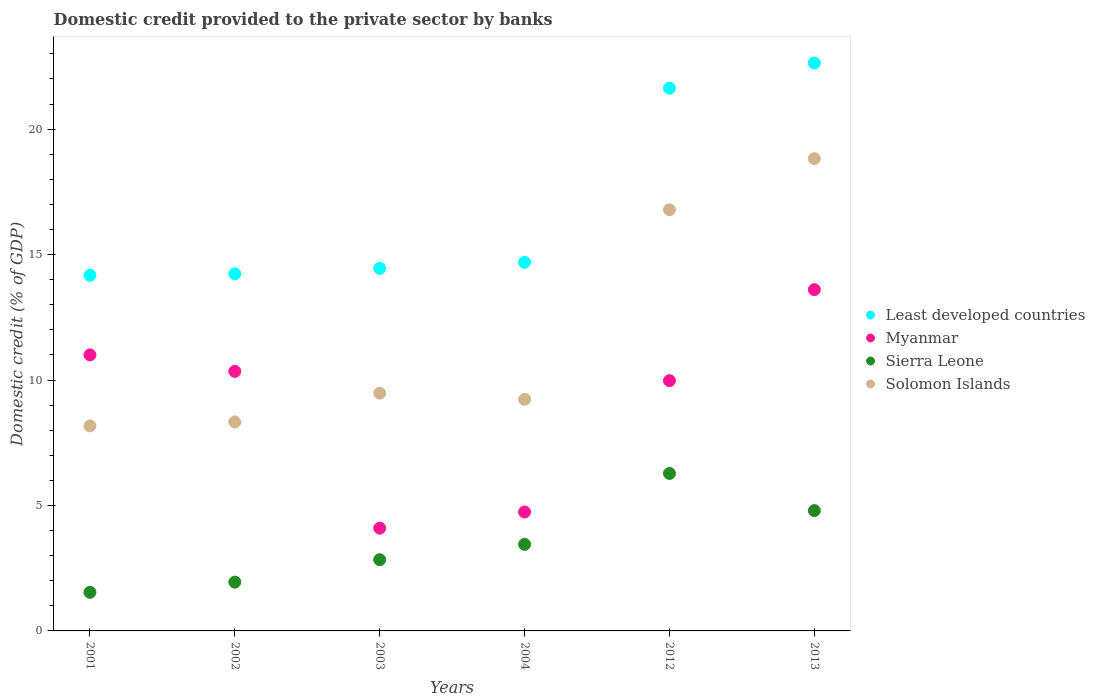What is the domestic credit provided to the private sector by banks in Sierra Leone in 2004?
Provide a short and direct response. 3.45. Across all years, what is the maximum domestic credit provided to the private sector by banks in Myanmar?
Give a very brief answer. 13.6. Across all years, what is the minimum domestic credit provided to the private sector by banks in Solomon Islands?
Offer a very short reply. 8.17. What is the total domestic credit provided to the private sector by banks in Least developed countries in the graph?
Your answer should be compact. 101.81. What is the difference between the domestic credit provided to the private sector by banks in Least developed countries in 2001 and that in 2012?
Keep it short and to the point. -7.46. What is the difference between the domestic credit provided to the private sector by banks in Sierra Leone in 2003 and the domestic credit provided to the private sector by banks in Solomon Islands in 2012?
Provide a short and direct response. -13.95. What is the average domestic credit provided to the private sector by banks in Sierra Leone per year?
Offer a very short reply. 3.47. In the year 2001, what is the difference between the domestic credit provided to the private sector by banks in Myanmar and domestic credit provided to the private sector by banks in Least developed countries?
Provide a short and direct response. -3.17. In how many years, is the domestic credit provided to the private sector by banks in Sierra Leone greater than 7 %?
Provide a short and direct response. 0. What is the ratio of the domestic credit provided to the private sector by banks in Solomon Islands in 2003 to that in 2012?
Your answer should be compact. 0.56. Is the domestic credit provided to the private sector by banks in Myanmar in 2001 less than that in 2002?
Provide a succinct answer. No. Is the difference between the domestic credit provided to the private sector by banks in Myanmar in 2002 and 2013 greater than the difference between the domestic credit provided to the private sector by banks in Least developed countries in 2002 and 2013?
Make the answer very short. Yes. What is the difference between the highest and the second highest domestic credit provided to the private sector by banks in Sierra Leone?
Offer a terse response. 1.48. What is the difference between the highest and the lowest domestic credit provided to the private sector by banks in Solomon Islands?
Offer a terse response. 10.65. Is the sum of the domestic credit provided to the private sector by banks in Sierra Leone in 2002 and 2012 greater than the maximum domestic credit provided to the private sector by banks in Least developed countries across all years?
Offer a very short reply. No. Is it the case that in every year, the sum of the domestic credit provided to the private sector by banks in Solomon Islands and domestic credit provided to the private sector by banks in Sierra Leone  is greater than the domestic credit provided to the private sector by banks in Myanmar?
Offer a very short reply. No. Does the domestic credit provided to the private sector by banks in Sierra Leone monotonically increase over the years?
Make the answer very short. No. How many dotlines are there?
Offer a terse response. 4. How many years are there in the graph?
Give a very brief answer. 6. Are the values on the major ticks of Y-axis written in scientific E-notation?
Provide a succinct answer. No. Where does the legend appear in the graph?
Ensure brevity in your answer.  Center right. How are the legend labels stacked?
Keep it short and to the point. Vertical. What is the title of the graph?
Your response must be concise. Domestic credit provided to the private sector by banks. Does "Malaysia" appear as one of the legend labels in the graph?
Make the answer very short. No. What is the label or title of the X-axis?
Offer a terse response. Years. What is the label or title of the Y-axis?
Provide a short and direct response. Domestic credit (% of GDP). What is the Domestic credit (% of GDP) of Least developed countries in 2001?
Your answer should be compact. 14.17. What is the Domestic credit (% of GDP) in Myanmar in 2001?
Offer a terse response. 11. What is the Domestic credit (% of GDP) of Sierra Leone in 2001?
Your answer should be very brief. 1.54. What is the Domestic credit (% of GDP) of Solomon Islands in 2001?
Keep it short and to the point. 8.17. What is the Domestic credit (% of GDP) of Least developed countries in 2002?
Make the answer very short. 14.23. What is the Domestic credit (% of GDP) in Myanmar in 2002?
Provide a short and direct response. 10.34. What is the Domestic credit (% of GDP) in Sierra Leone in 2002?
Ensure brevity in your answer.  1.94. What is the Domestic credit (% of GDP) in Solomon Islands in 2002?
Provide a succinct answer. 8.33. What is the Domestic credit (% of GDP) in Least developed countries in 2003?
Your answer should be very brief. 14.45. What is the Domestic credit (% of GDP) in Myanmar in 2003?
Provide a succinct answer. 4.1. What is the Domestic credit (% of GDP) in Sierra Leone in 2003?
Offer a very short reply. 2.84. What is the Domestic credit (% of GDP) in Solomon Islands in 2003?
Your answer should be very brief. 9.48. What is the Domestic credit (% of GDP) of Least developed countries in 2004?
Give a very brief answer. 14.69. What is the Domestic credit (% of GDP) of Myanmar in 2004?
Provide a short and direct response. 4.74. What is the Domestic credit (% of GDP) in Sierra Leone in 2004?
Your response must be concise. 3.45. What is the Domestic credit (% of GDP) of Solomon Islands in 2004?
Make the answer very short. 9.23. What is the Domestic credit (% of GDP) of Least developed countries in 2012?
Provide a succinct answer. 21.63. What is the Domestic credit (% of GDP) in Myanmar in 2012?
Keep it short and to the point. 9.97. What is the Domestic credit (% of GDP) of Sierra Leone in 2012?
Offer a very short reply. 6.28. What is the Domestic credit (% of GDP) in Solomon Islands in 2012?
Keep it short and to the point. 16.79. What is the Domestic credit (% of GDP) of Least developed countries in 2013?
Offer a terse response. 22.63. What is the Domestic credit (% of GDP) in Myanmar in 2013?
Provide a short and direct response. 13.6. What is the Domestic credit (% of GDP) in Sierra Leone in 2013?
Ensure brevity in your answer.  4.79. What is the Domestic credit (% of GDP) of Solomon Islands in 2013?
Offer a very short reply. 18.82. Across all years, what is the maximum Domestic credit (% of GDP) of Least developed countries?
Your answer should be compact. 22.63. Across all years, what is the maximum Domestic credit (% of GDP) of Myanmar?
Offer a terse response. 13.6. Across all years, what is the maximum Domestic credit (% of GDP) in Sierra Leone?
Offer a very short reply. 6.28. Across all years, what is the maximum Domestic credit (% of GDP) in Solomon Islands?
Keep it short and to the point. 18.82. Across all years, what is the minimum Domestic credit (% of GDP) in Least developed countries?
Make the answer very short. 14.17. Across all years, what is the minimum Domestic credit (% of GDP) of Myanmar?
Offer a very short reply. 4.1. Across all years, what is the minimum Domestic credit (% of GDP) in Sierra Leone?
Give a very brief answer. 1.54. Across all years, what is the minimum Domestic credit (% of GDP) of Solomon Islands?
Provide a succinct answer. 8.17. What is the total Domestic credit (% of GDP) of Least developed countries in the graph?
Offer a very short reply. 101.81. What is the total Domestic credit (% of GDP) of Myanmar in the graph?
Give a very brief answer. 53.76. What is the total Domestic credit (% of GDP) in Sierra Leone in the graph?
Provide a short and direct response. 20.84. What is the total Domestic credit (% of GDP) of Solomon Islands in the graph?
Provide a short and direct response. 70.82. What is the difference between the Domestic credit (% of GDP) in Least developed countries in 2001 and that in 2002?
Make the answer very short. -0.06. What is the difference between the Domestic credit (% of GDP) in Myanmar in 2001 and that in 2002?
Offer a terse response. 0.66. What is the difference between the Domestic credit (% of GDP) in Sierra Leone in 2001 and that in 2002?
Your answer should be very brief. -0.41. What is the difference between the Domestic credit (% of GDP) of Solomon Islands in 2001 and that in 2002?
Your answer should be compact. -0.16. What is the difference between the Domestic credit (% of GDP) of Least developed countries in 2001 and that in 2003?
Keep it short and to the point. -0.28. What is the difference between the Domestic credit (% of GDP) in Myanmar in 2001 and that in 2003?
Your answer should be very brief. 6.91. What is the difference between the Domestic credit (% of GDP) of Sierra Leone in 2001 and that in 2003?
Your answer should be very brief. -1.3. What is the difference between the Domestic credit (% of GDP) in Solomon Islands in 2001 and that in 2003?
Provide a short and direct response. -1.31. What is the difference between the Domestic credit (% of GDP) in Least developed countries in 2001 and that in 2004?
Your response must be concise. -0.52. What is the difference between the Domestic credit (% of GDP) in Myanmar in 2001 and that in 2004?
Your response must be concise. 6.26. What is the difference between the Domestic credit (% of GDP) of Sierra Leone in 2001 and that in 2004?
Give a very brief answer. -1.91. What is the difference between the Domestic credit (% of GDP) of Solomon Islands in 2001 and that in 2004?
Provide a short and direct response. -1.06. What is the difference between the Domestic credit (% of GDP) in Least developed countries in 2001 and that in 2012?
Your response must be concise. -7.46. What is the difference between the Domestic credit (% of GDP) in Myanmar in 2001 and that in 2012?
Give a very brief answer. 1.03. What is the difference between the Domestic credit (% of GDP) in Sierra Leone in 2001 and that in 2012?
Offer a terse response. -4.74. What is the difference between the Domestic credit (% of GDP) in Solomon Islands in 2001 and that in 2012?
Give a very brief answer. -8.61. What is the difference between the Domestic credit (% of GDP) in Least developed countries in 2001 and that in 2013?
Ensure brevity in your answer.  -8.46. What is the difference between the Domestic credit (% of GDP) in Myanmar in 2001 and that in 2013?
Provide a short and direct response. -2.6. What is the difference between the Domestic credit (% of GDP) of Sierra Leone in 2001 and that in 2013?
Your answer should be very brief. -3.26. What is the difference between the Domestic credit (% of GDP) of Solomon Islands in 2001 and that in 2013?
Offer a terse response. -10.65. What is the difference between the Domestic credit (% of GDP) in Least developed countries in 2002 and that in 2003?
Give a very brief answer. -0.22. What is the difference between the Domestic credit (% of GDP) of Myanmar in 2002 and that in 2003?
Offer a very short reply. 6.25. What is the difference between the Domestic credit (% of GDP) in Sierra Leone in 2002 and that in 2003?
Keep it short and to the point. -0.89. What is the difference between the Domestic credit (% of GDP) in Solomon Islands in 2002 and that in 2003?
Make the answer very short. -1.15. What is the difference between the Domestic credit (% of GDP) in Least developed countries in 2002 and that in 2004?
Offer a terse response. -0.46. What is the difference between the Domestic credit (% of GDP) of Myanmar in 2002 and that in 2004?
Your answer should be compact. 5.6. What is the difference between the Domestic credit (% of GDP) in Sierra Leone in 2002 and that in 2004?
Provide a short and direct response. -1.51. What is the difference between the Domestic credit (% of GDP) of Solomon Islands in 2002 and that in 2004?
Offer a terse response. -0.9. What is the difference between the Domestic credit (% of GDP) of Least developed countries in 2002 and that in 2012?
Your response must be concise. -7.4. What is the difference between the Domestic credit (% of GDP) in Myanmar in 2002 and that in 2012?
Give a very brief answer. 0.37. What is the difference between the Domestic credit (% of GDP) of Sierra Leone in 2002 and that in 2012?
Ensure brevity in your answer.  -4.33. What is the difference between the Domestic credit (% of GDP) in Solomon Islands in 2002 and that in 2012?
Your answer should be compact. -8.46. What is the difference between the Domestic credit (% of GDP) in Least developed countries in 2002 and that in 2013?
Provide a short and direct response. -8.4. What is the difference between the Domestic credit (% of GDP) in Myanmar in 2002 and that in 2013?
Give a very brief answer. -3.26. What is the difference between the Domestic credit (% of GDP) in Sierra Leone in 2002 and that in 2013?
Your answer should be compact. -2.85. What is the difference between the Domestic credit (% of GDP) of Solomon Islands in 2002 and that in 2013?
Your answer should be very brief. -10.5. What is the difference between the Domestic credit (% of GDP) of Least developed countries in 2003 and that in 2004?
Ensure brevity in your answer.  -0.24. What is the difference between the Domestic credit (% of GDP) of Myanmar in 2003 and that in 2004?
Your answer should be very brief. -0.64. What is the difference between the Domestic credit (% of GDP) in Sierra Leone in 2003 and that in 2004?
Keep it short and to the point. -0.61. What is the difference between the Domestic credit (% of GDP) of Solomon Islands in 2003 and that in 2004?
Give a very brief answer. 0.25. What is the difference between the Domestic credit (% of GDP) of Least developed countries in 2003 and that in 2012?
Offer a very short reply. -7.18. What is the difference between the Domestic credit (% of GDP) in Myanmar in 2003 and that in 2012?
Provide a short and direct response. -5.88. What is the difference between the Domestic credit (% of GDP) of Sierra Leone in 2003 and that in 2012?
Your response must be concise. -3.44. What is the difference between the Domestic credit (% of GDP) in Solomon Islands in 2003 and that in 2012?
Keep it short and to the point. -7.31. What is the difference between the Domestic credit (% of GDP) of Least developed countries in 2003 and that in 2013?
Your response must be concise. -8.18. What is the difference between the Domestic credit (% of GDP) in Myanmar in 2003 and that in 2013?
Ensure brevity in your answer.  -9.51. What is the difference between the Domestic credit (% of GDP) of Sierra Leone in 2003 and that in 2013?
Provide a short and direct response. -1.96. What is the difference between the Domestic credit (% of GDP) in Solomon Islands in 2003 and that in 2013?
Provide a succinct answer. -9.35. What is the difference between the Domestic credit (% of GDP) in Least developed countries in 2004 and that in 2012?
Keep it short and to the point. -6.94. What is the difference between the Domestic credit (% of GDP) of Myanmar in 2004 and that in 2012?
Provide a succinct answer. -5.23. What is the difference between the Domestic credit (% of GDP) in Sierra Leone in 2004 and that in 2012?
Ensure brevity in your answer.  -2.83. What is the difference between the Domestic credit (% of GDP) of Solomon Islands in 2004 and that in 2012?
Provide a succinct answer. -7.55. What is the difference between the Domestic credit (% of GDP) in Least developed countries in 2004 and that in 2013?
Make the answer very short. -7.94. What is the difference between the Domestic credit (% of GDP) in Myanmar in 2004 and that in 2013?
Give a very brief answer. -8.86. What is the difference between the Domestic credit (% of GDP) in Sierra Leone in 2004 and that in 2013?
Make the answer very short. -1.35. What is the difference between the Domestic credit (% of GDP) of Solomon Islands in 2004 and that in 2013?
Your answer should be very brief. -9.59. What is the difference between the Domestic credit (% of GDP) of Least developed countries in 2012 and that in 2013?
Make the answer very short. -1. What is the difference between the Domestic credit (% of GDP) in Myanmar in 2012 and that in 2013?
Make the answer very short. -3.63. What is the difference between the Domestic credit (% of GDP) in Sierra Leone in 2012 and that in 2013?
Your response must be concise. 1.48. What is the difference between the Domestic credit (% of GDP) of Solomon Islands in 2012 and that in 2013?
Provide a short and direct response. -2.04. What is the difference between the Domestic credit (% of GDP) in Least developed countries in 2001 and the Domestic credit (% of GDP) in Myanmar in 2002?
Keep it short and to the point. 3.83. What is the difference between the Domestic credit (% of GDP) of Least developed countries in 2001 and the Domestic credit (% of GDP) of Sierra Leone in 2002?
Your answer should be very brief. 12.23. What is the difference between the Domestic credit (% of GDP) of Least developed countries in 2001 and the Domestic credit (% of GDP) of Solomon Islands in 2002?
Keep it short and to the point. 5.84. What is the difference between the Domestic credit (% of GDP) of Myanmar in 2001 and the Domestic credit (% of GDP) of Sierra Leone in 2002?
Your response must be concise. 9.06. What is the difference between the Domestic credit (% of GDP) of Myanmar in 2001 and the Domestic credit (% of GDP) of Solomon Islands in 2002?
Your answer should be compact. 2.67. What is the difference between the Domestic credit (% of GDP) of Sierra Leone in 2001 and the Domestic credit (% of GDP) of Solomon Islands in 2002?
Give a very brief answer. -6.79. What is the difference between the Domestic credit (% of GDP) of Least developed countries in 2001 and the Domestic credit (% of GDP) of Myanmar in 2003?
Your answer should be very brief. 10.08. What is the difference between the Domestic credit (% of GDP) in Least developed countries in 2001 and the Domestic credit (% of GDP) in Sierra Leone in 2003?
Provide a succinct answer. 11.33. What is the difference between the Domestic credit (% of GDP) in Least developed countries in 2001 and the Domestic credit (% of GDP) in Solomon Islands in 2003?
Offer a terse response. 4.69. What is the difference between the Domestic credit (% of GDP) of Myanmar in 2001 and the Domestic credit (% of GDP) of Sierra Leone in 2003?
Offer a terse response. 8.16. What is the difference between the Domestic credit (% of GDP) of Myanmar in 2001 and the Domestic credit (% of GDP) of Solomon Islands in 2003?
Your response must be concise. 1.53. What is the difference between the Domestic credit (% of GDP) in Sierra Leone in 2001 and the Domestic credit (% of GDP) in Solomon Islands in 2003?
Your answer should be very brief. -7.94. What is the difference between the Domestic credit (% of GDP) in Least developed countries in 2001 and the Domestic credit (% of GDP) in Myanmar in 2004?
Your response must be concise. 9.43. What is the difference between the Domestic credit (% of GDP) in Least developed countries in 2001 and the Domestic credit (% of GDP) in Sierra Leone in 2004?
Make the answer very short. 10.72. What is the difference between the Domestic credit (% of GDP) of Least developed countries in 2001 and the Domestic credit (% of GDP) of Solomon Islands in 2004?
Offer a very short reply. 4.94. What is the difference between the Domestic credit (% of GDP) in Myanmar in 2001 and the Domestic credit (% of GDP) in Sierra Leone in 2004?
Make the answer very short. 7.55. What is the difference between the Domestic credit (% of GDP) of Myanmar in 2001 and the Domestic credit (% of GDP) of Solomon Islands in 2004?
Ensure brevity in your answer.  1.77. What is the difference between the Domestic credit (% of GDP) in Sierra Leone in 2001 and the Domestic credit (% of GDP) in Solomon Islands in 2004?
Your response must be concise. -7.69. What is the difference between the Domestic credit (% of GDP) of Least developed countries in 2001 and the Domestic credit (% of GDP) of Myanmar in 2012?
Provide a short and direct response. 4.2. What is the difference between the Domestic credit (% of GDP) of Least developed countries in 2001 and the Domestic credit (% of GDP) of Sierra Leone in 2012?
Keep it short and to the point. 7.89. What is the difference between the Domestic credit (% of GDP) of Least developed countries in 2001 and the Domestic credit (% of GDP) of Solomon Islands in 2012?
Offer a very short reply. -2.61. What is the difference between the Domestic credit (% of GDP) in Myanmar in 2001 and the Domestic credit (% of GDP) in Sierra Leone in 2012?
Provide a short and direct response. 4.72. What is the difference between the Domestic credit (% of GDP) of Myanmar in 2001 and the Domestic credit (% of GDP) of Solomon Islands in 2012?
Your answer should be very brief. -5.78. What is the difference between the Domestic credit (% of GDP) of Sierra Leone in 2001 and the Domestic credit (% of GDP) of Solomon Islands in 2012?
Provide a short and direct response. -15.25. What is the difference between the Domestic credit (% of GDP) of Least developed countries in 2001 and the Domestic credit (% of GDP) of Myanmar in 2013?
Ensure brevity in your answer.  0.57. What is the difference between the Domestic credit (% of GDP) in Least developed countries in 2001 and the Domestic credit (% of GDP) in Sierra Leone in 2013?
Provide a short and direct response. 9.38. What is the difference between the Domestic credit (% of GDP) in Least developed countries in 2001 and the Domestic credit (% of GDP) in Solomon Islands in 2013?
Provide a succinct answer. -4.65. What is the difference between the Domestic credit (% of GDP) in Myanmar in 2001 and the Domestic credit (% of GDP) in Sierra Leone in 2013?
Offer a terse response. 6.21. What is the difference between the Domestic credit (% of GDP) of Myanmar in 2001 and the Domestic credit (% of GDP) of Solomon Islands in 2013?
Offer a terse response. -7.82. What is the difference between the Domestic credit (% of GDP) of Sierra Leone in 2001 and the Domestic credit (% of GDP) of Solomon Islands in 2013?
Provide a short and direct response. -17.29. What is the difference between the Domestic credit (% of GDP) in Least developed countries in 2002 and the Domestic credit (% of GDP) in Myanmar in 2003?
Provide a succinct answer. 10.14. What is the difference between the Domestic credit (% of GDP) of Least developed countries in 2002 and the Domestic credit (% of GDP) of Sierra Leone in 2003?
Provide a succinct answer. 11.39. What is the difference between the Domestic credit (% of GDP) in Least developed countries in 2002 and the Domestic credit (% of GDP) in Solomon Islands in 2003?
Keep it short and to the point. 4.76. What is the difference between the Domestic credit (% of GDP) in Myanmar in 2002 and the Domestic credit (% of GDP) in Sierra Leone in 2003?
Make the answer very short. 7.51. What is the difference between the Domestic credit (% of GDP) of Myanmar in 2002 and the Domestic credit (% of GDP) of Solomon Islands in 2003?
Keep it short and to the point. 0.87. What is the difference between the Domestic credit (% of GDP) in Sierra Leone in 2002 and the Domestic credit (% of GDP) in Solomon Islands in 2003?
Provide a short and direct response. -7.53. What is the difference between the Domestic credit (% of GDP) of Least developed countries in 2002 and the Domestic credit (% of GDP) of Myanmar in 2004?
Keep it short and to the point. 9.49. What is the difference between the Domestic credit (% of GDP) in Least developed countries in 2002 and the Domestic credit (% of GDP) in Sierra Leone in 2004?
Your answer should be compact. 10.78. What is the difference between the Domestic credit (% of GDP) in Least developed countries in 2002 and the Domestic credit (% of GDP) in Solomon Islands in 2004?
Provide a short and direct response. 5. What is the difference between the Domestic credit (% of GDP) in Myanmar in 2002 and the Domestic credit (% of GDP) in Sierra Leone in 2004?
Make the answer very short. 6.9. What is the difference between the Domestic credit (% of GDP) in Myanmar in 2002 and the Domestic credit (% of GDP) in Solomon Islands in 2004?
Provide a short and direct response. 1.11. What is the difference between the Domestic credit (% of GDP) of Sierra Leone in 2002 and the Domestic credit (% of GDP) of Solomon Islands in 2004?
Your response must be concise. -7.29. What is the difference between the Domestic credit (% of GDP) of Least developed countries in 2002 and the Domestic credit (% of GDP) of Myanmar in 2012?
Your response must be concise. 4.26. What is the difference between the Domestic credit (% of GDP) of Least developed countries in 2002 and the Domestic credit (% of GDP) of Sierra Leone in 2012?
Your response must be concise. 7.95. What is the difference between the Domestic credit (% of GDP) in Least developed countries in 2002 and the Domestic credit (% of GDP) in Solomon Islands in 2012?
Ensure brevity in your answer.  -2.55. What is the difference between the Domestic credit (% of GDP) of Myanmar in 2002 and the Domestic credit (% of GDP) of Sierra Leone in 2012?
Offer a terse response. 4.07. What is the difference between the Domestic credit (% of GDP) in Myanmar in 2002 and the Domestic credit (% of GDP) in Solomon Islands in 2012?
Offer a very short reply. -6.44. What is the difference between the Domestic credit (% of GDP) in Sierra Leone in 2002 and the Domestic credit (% of GDP) in Solomon Islands in 2012?
Your answer should be compact. -14.84. What is the difference between the Domestic credit (% of GDP) in Least developed countries in 2002 and the Domestic credit (% of GDP) in Myanmar in 2013?
Offer a terse response. 0.63. What is the difference between the Domestic credit (% of GDP) in Least developed countries in 2002 and the Domestic credit (% of GDP) in Sierra Leone in 2013?
Your response must be concise. 9.44. What is the difference between the Domestic credit (% of GDP) of Least developed countries in 2002 and the Domestic credit (% of GDP) of Solomon Islands in 2013?
Your response must be concise. -4.59. What is the difference between the Domestic credit (% of GDP) in Myanmar in 2002 and the Domestic credit (% of GDP) in Sierra Leone in 2013?
Give a very brief answer. 5.55. What is the difference between the Domestic credit (% of GDP) in Myanmar in 2002 and the Domestic credit (% of GDP) in Solomon Islands in 2013?
Ensure brevity in your answer.  -8.48. What is the difference between the Domestic credit (% of GDP) in Sierra Leone in 2002 and the Domestic credit (% of GDP) in Solomon Islands in 2013?
Your response must be concise. -16.88. What is the difference between the Domestic credit (% of GDP) in Least developed countries in 2003 and the Domestic credit (% of GDP) in Myanmar in 2004?
Keep it short and to the point. 9.71. What is the difference between the Domestic credit (% of GDP) of Least developed countries in 2003 and the Domestic credit (% of GDP) of Sierra Leone in 2004?
Provide a short and direct response. 11. What is the difference between the Domestic credit (% of GDP) of Least developed countries in 2003 and the Domestic credit (% of GDP) of Solomon Islands in 2004?
Provide a succinct answer. 5.22. What is the difference between the Domestic credit (% of GDP) of Myanmar in 2003 and the Domestic credit (% of GDP) of Sierra Leone in 2004?
Make the answer very short. 0.65. What is the difference between the Domestic credit (% of GDP) in Myanmar in 2003 and the Domestic credit (% of GDP) in Solomon Islands in 2004?
Your answer should be very brief. -5.14. What is the difference between the Domestic credit (% of GDP) of Sierra Leone in 2003 and the Domestic credit (% of GDP) of Solomon Islands in 2004?
Provide a succinct answer. -6.39. What is the difference between the Domestic credit (% of GDP) of Least developed countries in 2003 and the Domestic credit (% of GDP) of Myanmar in 2012?
Provide a short and direct response. 4.48. What is the difference between the Domestic credit (% of GDP) of Least developed countries in 2003 and the Domestic credit (% of GDP) of Sierra Leone in 2012?
Keep it short and to the point. 8.17. What is the difference between the Domestic credit (% of GDP) in Least developed countries in 2003 and the Domestic credit (% of GDP) in Solomon Islands in 2012?
Provide a succinct answer. -2.34. What is the difference between the Domestic credit (% of GDP) of Myanmar in 2003 and the Domestic credit (% of GDP) of Sierra Leone in 2012?
Your answer should be very brief. -2.18. What is the difference between the Domestic credit (% of GDP) of Myanmar in 2003 and the Domestic credit (% of GDP) of Solomon Islands in 2012?
Give a very brief answer. -12.69. What is the difference between the Domestic credit (% of GDP) of Sierra Leone in 2003 and the Domestic credit (% of GDP) of Solomon Islands in 2012?
Offer a very short reply. -13.95. What is the difference between the Domestic credit (% of GDP) of Least developed countries in 2003 and the Domestic credit (% of GDP) of Myanmar in 2013?
Provide a succinct answer. 0.85. What is the difference between the Domestic credit (% of GDP) of Least developed countries in 2003 and the Domestic credit (% of GDP) of Sierra Leone in 2013?
Ensure brevity in your answer.  9.65. What is the difference between the Domestic credit (% of GDP) in Least developed countries in 2003 and the Domestic credit (% of GDP) in Solomon Islands in 2013?
Offer a terse response. -4.37. What is the difference between the Domestic credit (% of GDP) of Myanmar in 2003 and the Domestic credit (% of GDP) of Sierra Leone in 2013?
Offer a terse response. -0.7. What is the difference between the Domestic credit (% of GDP) of Myanmar in 2003 and the Domestic credit (% of GDP) of Solomon Islands in 2013?
Provide a short and direct response. -14.73. What is the difference between the Domestic credit (% of GDP) of Sierra Leone in 2003 and the Domestic credit (% of GDP) of Solomon Islands in 2013?
Offer a terse response. -15.98. What is the difference between the Domestic credit (% of GDP) of Least developed countries in 2004 and the Domestic credit (% of GDP) of Myanmar in 2012?
Your answer should be compact. 4.72. What is the difference between the Domestic credit (% of GDP) of Least developed countries in 2004 and the Domestic credit (% of GDP) of Sierra Leone in 2012?
Make the answer very short. 8.41. What is the difference between the Domestic credit (% of GDP) in Least developed countries in 2004 and the Domestic credit (% of GDP) in Solomon Islands in 2012?
Your answer should be compact. -2.09. What is the difference between the Domestic credit (% of GDP) of Myanmar in 2004 and the Domestic credit (% of GDP) of Sierra Leone in 2012?
Your answer should be very brief. -1.54. What is the difference between the Domestic credit (% of GDP) of Myanmar in 2004 and the Domestic credit (% of GDP) of Solomon Islands in 2012?
Your response must be concise. -12.05. What is the difference between the Domestic credit (% of GDP) in Sierra Leone in 2004 and the Domestic credit (% of GDP) in Solomon Islands in 2012?
Ensure brevity in your answer.  -13.34. What is the difference between the Domestic credit (% of GDP) of Least developed countries in 2004 and the Domestic credit (% of GDP) of Myanmar in 2013?
Offer a very short reply. 1.09. What is the difference between the Domestic credit (% of GDP) of Least developed countries in 2004 and the Domestic credit (% of GDP) of Sierra Leone in 2013?
Your answer should be very brief. 9.9. What is the difference between the Domestic credit (% of GDP) in Least developed countries in 2004 and the Domestic credit (% of GDP) in Solomon Islands in 2013?
Your answer should be very brief. -4.13. What is the difference between the Domestic credit (% of GDP) of Myanmar in 2004 and the Domestic credit (% of GDP) of Sierra Leone in 2013?
Give a very brief answer. -0.05. What is the difference between the Domestic credit (% of GDP) in Myanmar in 2004 and the Domestic credit (% of GDP) in Solomon Islands in 2013?
Provide a short and direct response. -14.08. What is the difference between the Domestic credit (% of GDP) in Sierra Leone in 2004 and the Domestic credit (% of GDP) in Solomon Islands in 2013?
Provide a succinct answer. -15.37. What is the difference between the Domestic credit (% of GDP) of Least developed countries in 2012 and the Domestic credit (% of GDP) of Myanmar in 2013?
Keep it short and to the point. 8.03. What is the difference between the Domestic credit (% of GDP) in Least developed countries in 2012 and the Domestic credit (% of GDP) in Sierra Leone in 2013?
Your response must be concise. 16.84. What is the difference between the Domestic credit (% of GDP) of Least developed countries in 2012 and the Domestic credit (% of GDP) of Solomon Islands in 2013?
Provide a short and direct response. 2.81. What is the difference between the Domestic credit (% of GDP) of Myanmar in 2012 and the Domestic credit (% of GDP) of Sierra Leone in 2013?
Your answer should be compact. 5.18. What is the difference between the Domestic credit (% of GDP) of Myanmar in 2012 and the Domestic credit (% of GDP) of Solomon Islands in 2013?
Offer a very short reply. -8.85. What is the difference between the Domestic credit (% of GDP) in Sierra Leone in 2012 and the Domestic credit (% of GDP) in Solomon Islands in 2013?
Your answer should be very brief. -12.55. What is the average Domestic credit (% of GDP) of Least developed countries per year?
Ensure brevity in your answer.  16.97. What is the average Domestic credit (% of GDP) of Myanmar per year?
Give a very brief answer. 8.96. What is the average Domestic credit (% of GDP) in Sierra Leone per year?
Make the answer very short. 3.47. What is the average Domestic credit (% of GDP) in Solomon Islands per year?
Make the answer very short. 11.8. In the year 2001, what is the difference between the Domestic credit (% of GDP) in Least developed countries and Domestic credit (% of GDP) in Myanmar?
Provide a short and direct response. 3.17. In the year 2001, what is the difference between the Domestic credit (% of GDP) of Least developed countries and Domestic credit (% of GDP) of Sierra Leone?
Ensure brevity in your answer.  12.63. In the year 2001, what is the difference between the Domestic credit (% of GDP) of Myanmar and Domestic credit (% of GDP) of Sierra Leone?
Give a very brief answer. 9.46. In the year 2001, what is the difference between the Domestic credit (% of GDP) of Myanmar and Domestic credit (% of GDP) of Solomon Islands?
Your response must be concise. 2.83. In the year 2001, what is the difference between the Domestic credit (% of GDP) in Sierra Leone and Domestic credit (% of GDP) in Solomon Islands?
Ensure brevity in your answer.  -6.63. In the year 2002, what is the difference between the Domestic credit (% of GDP) of Least developed countries and Domestic credit (% of GDP) of Myanmar?
Your response must be concise. 3.89. In the year 2002, what is the difference between the Domestic credit (% of GDP) in Least developed countries and Domestic credit (% of GDP) in Sierra Leone?
Make the answer very short. 12.29. In the year 2002, what is the difference between the Domestic credit (% of GDP) in Least developed countries and Domestic credit (% of GDP) in Solomon Islands?
Keep it short and to the point. 5.9. In the year 2002, what is the difference between the Domestic credit (% of GDP) in Myanmar and Domestic credit (% of GDP) in Sierra Leone?
Give a very brief answer. 8.4. In the year 2002, what is the difference between the Domestic credit (% of GDP) in Myanmar and Domestic credit (% of GDP) in Solomon Islands?
Your response must be concise. 2.02. In the year 2002, what is the difference between the Domestic credit (% of GDP) of Sierra Leone and Domestic credit (% of GDP) of Solomon Islands?
Your answer should be compact. -6.38. In the year 2003, what is the difference between the Domestic credit (% of GDP) of Least developed countries and Domestic credit (% of GDP) of Myanmar?
Offer a terse response. 10.35. In the year 2003, what is the difference between the Domestic credit (% of GDP) of Least developed countries and Domestic credit (% of GDP) of Sierra Leone?
Provide a succinct answer. 11.61. In the year 2003, what is the difference between the Domestic credit (% of GDP) in Least developed countries and Domestic credit (% of GDP) in Solomon Islands?
Make the answer very short. 4.97. In the year 2003, what is the difference between the Domestic credit (% of GDP) in Myanmar and Domestic credit (% of GDP) in Sierra Leone?
Give a very brief answer. 1.26. In the year 2003, what is the difference between the Domestic credit (% of GDP) in Myanmar and Domestic credit (% of GDP) in Solomon Islands?
Keep it short and to the point. -5.38. In the year 2003, what is the difference between the Domestic credit (% of GDP) in Sierra Leone and Domestic credit (% of GDP) in Solomon Islands?
Offer a very short reply. -6.64. In the year 2004, what is the difference between the Domestic credit (% of GDP) of Least developed countries and Domestic credit (% of GDP) of Myanmar?
Your answer should be very brief. 9.95. In the year 2004, what is the difference between the Domestic credit (% of GDP) in Least developed countries and Domestic credit (% of GDP) in Sierra Leone?
Provide a short and direct response. 11.24. In the year 2004, what is the difference between the Domestic credit (% of GDP) of Least developed countries and Domestic credit (% of GDP) of Solomon Islands?
Your answer should be very brief. 5.46. In the year 2004, what is the difference between the Domestic credit (% of GDP) of Myanmar and Domestic credit (% of GDP) of Sierra Leone?
Provide a succinct answer. 1.29. In the year 2004, what is the difference between the Domestic credit (% of GDP) of Myanmar and Domestic credit (% of GDP) of Solomon Islands?
Offer a terse response. -4.49. In the year 2004, what is the difference between the Domestic credit (% of GDP) in Sierra Leone and Domestic credit (% of GDP) in Solomon Islands?
Provide a short and direct response. -5.78. In the year 2012, what is the difference between the Domestic credit (% of GDP) of Least developed countries and Domestic credit (% of GDP) of Myanmar?
Provide a succinct answer. 11.66. In the year 2012, what is the difference between the Domestic credit (% of GDP) of Least developed countries and Domestic credit (% of GDP) of Sierra Leone?
Offer a very short reply. 15.35. In the year 2012, what is the difference between the Domestic credit (% of GDP) in Least developed countries and Domestic credit (% of GDP) in Solomon Islands?
Make the answer very short. 4.84. In the year 2012, what is the difference between the Domestic credit (% of GDP) in Myanmar and Domestic credit (% of GDP) in Sierra Leone?
Offer a terse response. 3.7. In the year 2012, what is the difference between the Domestic credit (% of GDP) in Myanmar and Domestic credit (% of GDP) in Solomon Islands?
Your answer should be compact. -6.81. In the year 2012, what is the difference between the Domestic credit (% of GDP) in Sierra Leone and Domestic credit (% of GDP) in Solomon Islands?
Provide a succinct answer. -10.51. In the year 2013, what is the difference between the Domestic credit (% of GDP) in Least developed countries and Domestic credit (% of GDP) in Myanmar?
Your response must be concise. 9.03. In the year 2013, what is the difference between the Domestic credit (% of GDP) of Least developed countries and Domestic credit (% of GDP) of Sierra Leone?
Provide a short and direct response. 17.84. In the year 2013, what is the difference between the Domestic credit (% of GDP) of Least developed countries and Domestic credit (% of GDP) of Solomon Islands?
Give a very brief answer. 3.81. In the year 2013, what is the difference between the Domestic credit (% of GDP) in Myanmar and Domestic credit (% of GDP) in Sierra Leone?
Keep it short and to the point. 8.81. In the year 2013, what is the difference between the Domestic credit (% of GDP) in Myanmar and Domestic credit (% of GDP) in Solomon Islands?
Offer a terse response. -5.22. In the year 2013, what is the difference between the Domestic credit (% of GDP) in Sierra Leone and Domestic credit (% of GDP) in Solomon Islands?
Provide a short and direct response. -14.03. What is the ratio of the Domestic credit (% of GDP) in Myanmar in 2001 to that in 2002?
Offer a terse response. 1.06. What is the ratio of the Domestic credit (% of GDP) in Sierra Leone in 2001 to that in 2002?
Your answer should be very brief. 0.79. What is the ratio of the Domestic credit (% of GDP) in Solomon Islands in 2001 to that in 2002?
Offer a terse response. 0.98. What is the ratio of the Domestic credit (% of GDP) of Least developed countries in 2001 to that in 2003?
Keep it short and to the point. 0.98. What is the ratio of the Domestic credit (% of GDP) in Myanmar in 2001 to that in 2003?
Ensure brevity in your answer.  2.69. What is the ratio of the Domestic credit (% of GDP) of Sierra Leone in 2001 to that in 2003?
Offer a terse response. 0.54. What is the ratio of the Domestic credit (% of GDP) of Solomon Islands in 2001 to that in 2003?
Your response must be concise. 0.86. What is the ratio of the Domestic credit (% of GDP) of Least developed countries in 2001 to that in 2004?
Make the answer very short. 0.96. What is the ratio of the Domestic credit (% of GDP) in Myanmar in 2001 to that in 2004?
Your answer should be very brief. 2.32. What is the ratio of the Domestic credit (% of GDP) in Sierra Leone in 2001 to that in 2004?
Your answer should be very brief. 0.45. What is the ratio of the Domestic credit (% of GDP) of Solomon Islands in 2001 to that in 2004?
Give a very brief answer. 0.89. What is the ratio of the Domestic credit (% of GDP) in Least developed countries in 2001 to that in 2012?
Provide a succinct answer. 0.66. What is the ratio of the Domestic credit (% of GDP) of Myanmar in 2001 to that in 2012?
Your response must be concise. 1.1. What is the ratio of the Domestic credit (% of GDP) of Sierra Leone in 2001 to that in 2012?
Your answer should be compact. 0.24. What is the ratio of the Domestic credit (% of GDP) of Solomon Islands in 2001 to that in 2012?
Give a very brief answer. 0.49. What is the ratio of the Domestic credit (% of GDP) of Least developed countries in 2001 to that in 2013?
Ensure brevity in your answer.  0.63. What is the ratio of the Domestic credit (% of GDP) of Myanmar in 2001 to that in 2013?
Offer a very short reply. 0.81. What is the ratio of the Domestic credit (% of GDP) of Sierra Leone in 2001 to that in 2013?
Offer a very short reply. 0.32. What is the ratio of the Domestic credit (% of GDP) in Solomon Islands in 2001 to that in 2013?
Your answer should be compact. 0.43. What is the ratio of the Domestic credit (% of GDP) in Least developed countries in 2002 to that in 2003?
Give a very brief answer. 0.98. What is the ratio of the Domestic credit (% of GDP) of Myanmar in 2002 to that in 2003?
Provide a short and direct response. 2.53. What is the ratio of the Domestic credit (% of GDP) in Sierra Leone in 2002 to that in 2003?
Give a very brief answer. 0.68. What is the ratio of the Domestic credit (% of GDP) of Solomon Islands in 2002 to that in 2003?
Ensure brevity in your answer.  0.88. What is the ratio of the Domestic credit (% of GDP) in Least developed countries in 2002 to that in 2004?
Your answer should be very brief. 0.97. What is the ratio of the Domestic credit (% of GDP) in Myanmar in 2002 to that in 2004?
Your answer should be compact. 2.18. What is the ratio of the Domestic credit (% of GDP) of Sierra Leone in 2002 to that in 2004?
Give a very brief answer. 0.56. What is the ratio of the Domestic credit (% of GDP) of Solomon Islands in 2002 to that in 2004?
Your answer should be compact. 0.9. What is the ratio of the Domestic credit (% of GDP) of Least developed countries in 2002 to that in 2012?
Ensure brevity in your answer.  0.66. What is the ratio of the Domestic credit (% of GDP) in Myanmar in 2002 to that in 2012?
Provide a short and direct response. 1.04. What is the ratio of the Domestic credit (% of GDP) in Sierra Leone in 2002 to that in 2012?
Make the answer very short. 0.31. What is the ratio of the Domestic credit (% of GDP) of Solomon Islands in 2002 to that in 2012?
Offer a very short reply. 0.5. What is the ratio of the Domestic credit (% of GDP) in Least developed countries in 2002 to that in 2013?
Make the answer very short. 0.63. What is the ratio of the Domestic credit (% of GDP) in Myanmar in 2002 to that in 2013?
Your response must be concise. 0.76. What is the ratio of the Domestic credit (% of GDP) of Sierra Leone in 2002 to that in 2013?
Your answer should be very brief. 0.41. What is the ratio of the Domestic credit (% of GDP) in Solomon Islands in 2002 to that in 2013?
Provide a short and direct response. 0.44. What is the ratio of the Domestic credit (% of GDP) of Least developed countries in 2003 to that in 2004?
Provide a succinct answer. 0.98. What is the ratio of the Domestic credit (% of GDP) in Myanmar in 2003 to that in 2004?
Provide a short and direct response. 0.86. What is the ratio of the Domestic credit (% of GDP) of Sierra Leone in 2003 to that in 2004?
Your answer should be very brief. 0.82. What is the ratio of the Domestic credit (% of GDP) of Solomon Islands in 2003 to that in 2004?
Your answer should be very brief. 1.03. What is the ratio of the Domestic credit (% of GDP) in Least developed countries in 2003 to that in 2012?
Your answer should be compact. 0.67. What is the ratio of the Domestic credit (% of GDP) of Myanmar in 2003 to that in 2012?
Make the answer very short. 0.41. What is the ratio of the Domestic credit (% of GDP) of Sierra Leone in 2003 to that in 2012?
Provide a succinct answer. 0.45. What is the ratio of the Domestic credit (% of GDP) in Solomon Islands in 2003 to that in 2012?
Keep it short and to the point. 0.56. What is the ratio of the Domestic credit (% of GDP) of Least developed countries in 2003 to that in 2013?
Your answer should be very brief. 0.64. What is the ratio of the Domestic credit (% of GDP) of Myanmar in 2003 to that in 2013?
Offer a terse response. 0.3. What is the ratio of the Domestic credit (% of GDP) in Sierra Leone in 2003 to that in 2013?
Your response must be concise. 0.59. What is the ratio of the Domestic credit (% of GDP) in Solomon Islands in 2003 to that in 2013?
Ensure brevity in your answer.  0.5. What is the ratio of the Domestic credit (% of GDP) of Least developed countries in 2004 to that in 2012?
Provide a succinct answer. 0.68. What is the ratio of the Domestic credit (% of GDP) of Myanmar in 2004 to that in 2012?
Provide a succinct answer. 0.48. What is the ratio of the Domestic credit (% of GDP) of Sierra Leone in 2004 to that in 2012?
Provide a short and direct response. 0.55. What is the ratio of the Domestic credit (% of GDP) in Solomon Islands in 2004 to that in 2012?
Provide a succinct answer. 0.55. What is the ratio of the Domestic credit (% of GDP) of Least developed countries in 2004 to that in 2013?
Your answer should be compact. 0.65. What is the ratio of the Domestic credit (% of GDP) of Myanmar in 2004 to that in 2013?
Provide a succinct answer. 0.35. What is the ratio of the Domestic credit (% of GDP) of Sierra Leone in 2004 to that in 2013?
Your response must be concise. 0.72. What is the ratio of the Domestic credit (% of GDP) in Solomon Islands in 2004 to that in 2013?
Offer a terse response. 0.49. What is the ratio of the Domestic credit (% of GDP) in Least developed countries in 2012 to that in 2013?
Provide a short and direct response. 0.96. What is the ratio of the Domestic credit (% of GDP) of Myanmar in 2012 to that in 2013?
Offer a very short reply. 0.73. What is the ratio of the Domestic credit (% of GDP) in Sierra Leone in 2012 to that in 2013?
Your answer should be compact. 1.31. What is the ratio of the Domestic credit (% of GDP) in Solomon Islands in 2012 to that in 2013?
Offer a very short reply. 0.89. What is the difference between the highest and the second highest Domestic credit (% of GDP) in Myanmar?
Ensure brevity in your answer.  2.6. What is the difference between the highest and the second highest Domestic credit (% of GDP) of Sierra Leone?
Your answer should be compact. 1.48. What is the difference between the highest and the second highest Domestic credit (% of GDP) of Solomon Islands?
Provide a short and direct response. 2.04. What is the difference between the highest and the lowest Domestic credit (% of GDP) of Least developed countries?
Offer a very short reply. 8.46. What is the difference between the highest and the lowest Domestic credit (% of GDP) of Myanmar?
Offer a terse response. 9.51. What is the difference between the highest and the lowest Domestic credit (% of GDP) in Sierra Leone?
Your answer should be very brief. 4.74. What is the difference between the highest and the lowest Domestic credit (% of GDP) in Solomon Islands?
Your answer should be compact. 10.65. 